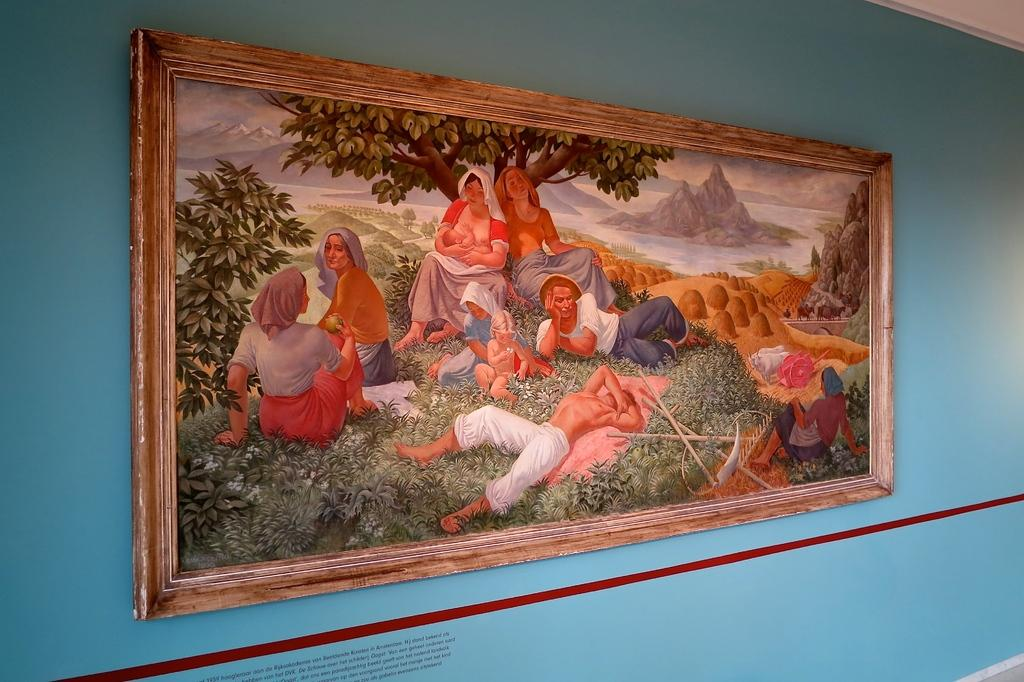What is the main subject of the image? The main subject of the image is a depiction picture. What can be seen in the depiction picture? There are people and trees in the depiction picture. What color is the wall in the image? There is a blue color wall in the image. What direction is the daughter facing in the image? There is no daughter present in the image, as the main subject is a depiction picture with people and trees. 